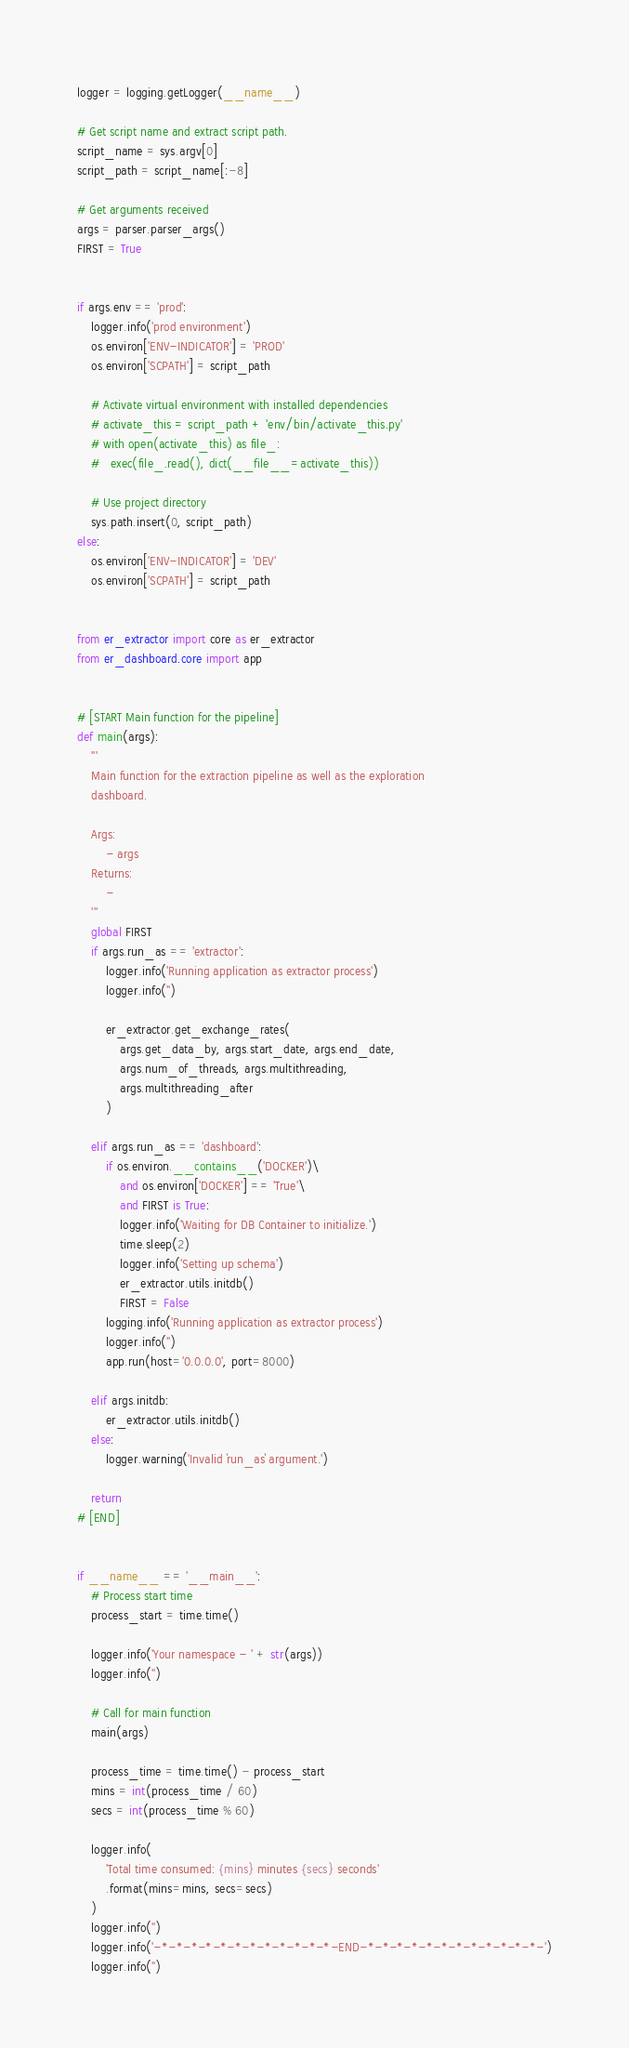Convert code to text. <code><loc_0><loc_0><loc_500><loc_500><_Python_>logger = logging.getLogger(__name__)

# Get script name and extract script path.
script_name = sys.argv[0]
script_path = script_name[:-8]

# Get arguments received
args = parser.parser_args()
FIRST = True


if args.env == 'prod':
	logger.info('prod environment')
	os.environ['ENV-INDICATOR'] = 'PROD'
	os.environ['SCPATH'] = script_path

	# Activate virtual environment with installed dependencies
	# activate_this = script_path + 'env/bin/activate_this.py'
	# with open(activate_this) as file_:
	# 	exec(file_.read(), dict(__file__=activate_this))

	# Use project directory
	sys.path.insert(0, script_path)
else:
	os.environ['ENV-INDICATOR'] = 'DEV'
	os.environ['SCPATH'] = script_path


from er_extractor import core as er_extractor
from er_dashboard.core import app


# [START Main function for the pipeline]
def main(args):
	'''
	Main function for the extraction pipeline as well as the exploration
	dashboard.

	Args:
		- args
	Returns:
		-
	'''
	global FIRST
	if args.run_as == 'extractor':
		logger.info('Running application as extractor process')
		logger.info('')

		er_extractor.get_exchange_rates(
			args.get_data_by, args.start_date, args.end_date,
			args.num_of_threads, args.multithreading,
			args.multithreading_after
		)

	elif args.run_as == 'dashboard':
		if os.environ.__contains__('DOCKER')\
			and os.environ['DOCKER'] == 'True'\
			and FIRST is True:
			logger.info('Waiting for DB Container to initialize.')
			time.sleep(2)
			logger.info('Setting up schema')
			er_extractor.utils.initdb()
			FIRST = False
		logging.info('Running application as extractor process')
		logger.info('')
		app.run(host='0.0.0.0', port=8000)

	elif args.initdb:
		er_extractor.utils.initdb()
	else:
		logger.warning('Invalid `run_as` argument.')

	return
# [END]


if __name__ == '__main__':
	# Process start time
	process_start = time.time()

	logger.info('Your namespace - ' + str(args))
	logger.info('')

	# Call for main function
	main(args)

	process_time = time.time() - process_start
	mins = int(process_time / 60)
	secs = int(process_time % 60)

	logger.info(
		'Total time consumed: {mins} minutes {secs} seconds'
		.format(mins=mins, secs=secs)
	)
	logger.info('')
	logger.info('-*-*-*-*-*-*-*-*-*-*-*-*-END-*-*-*-*-*-*-*-*-*-*-*-*-')
	logger.info('')
</code> 